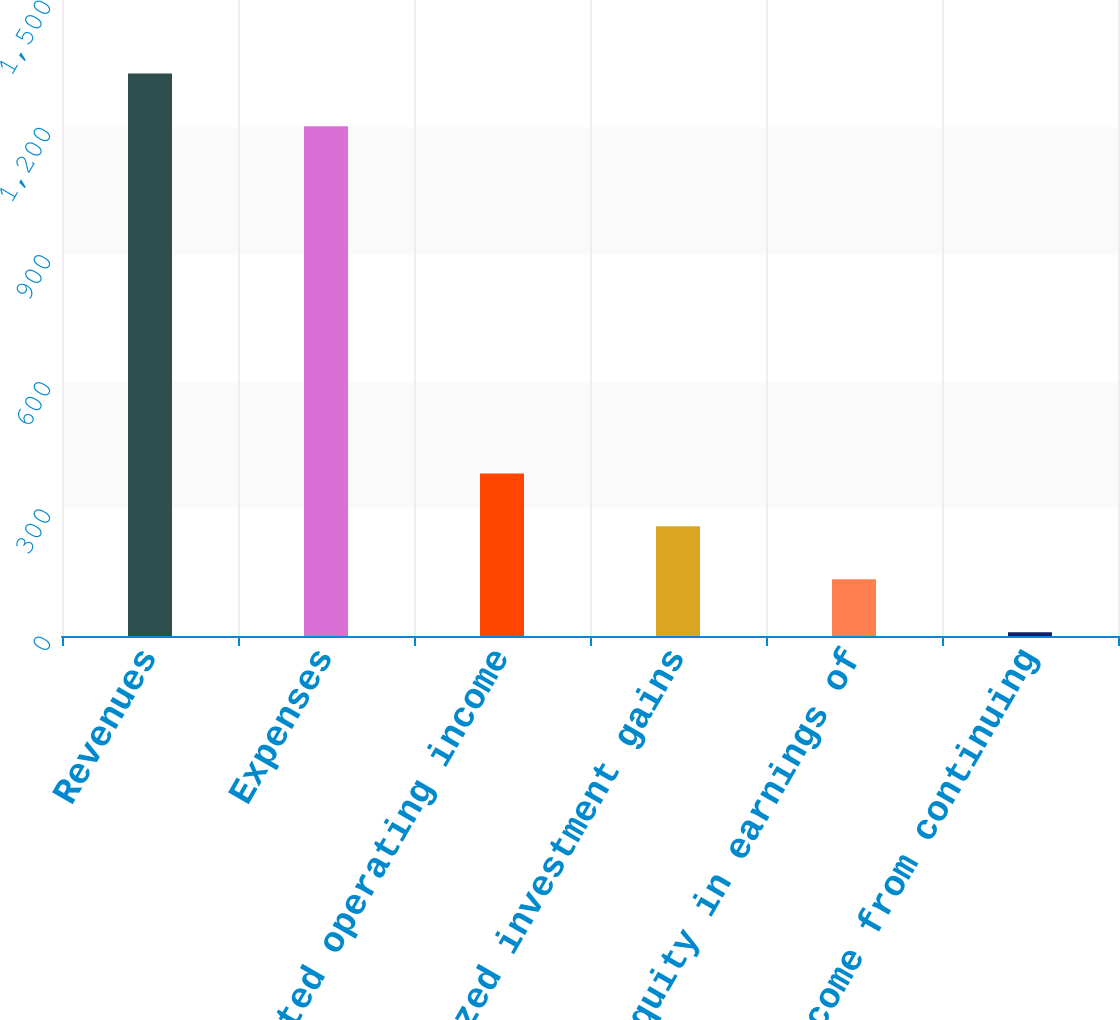<chart> <loc_0><loc_0><loc_500><loc_500><bar_chart><fcel>Revenues<fcel>Expenses<fcel>Adjusted operating income<fcel>Realized investment gains<fcel>Equity in earnings of<fcel>Income from continuing<nl><fcel>1326.8<fcel>1202<fcel>383.4<fcel>258.6<fcel>133.8<fcel>9<nl></chart> 